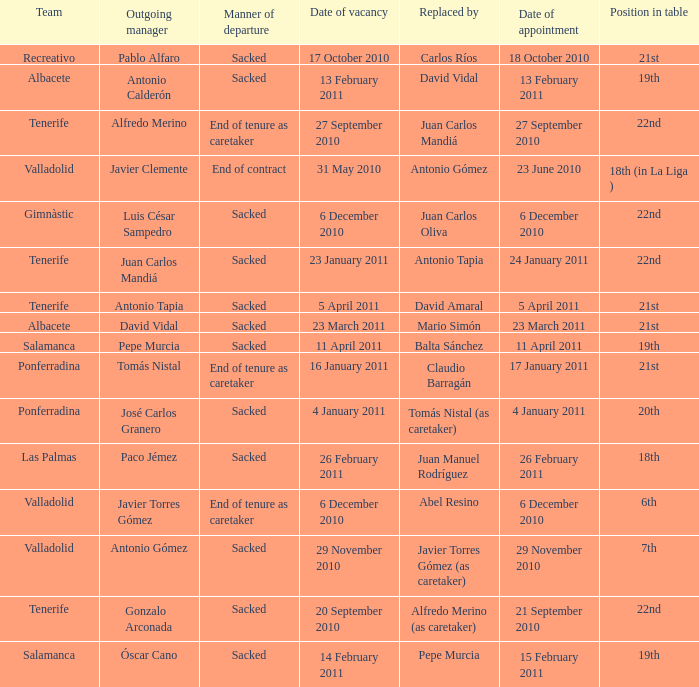What is the position for outgoing manager alfredo merino 22nd. Can you give me this table as a dict? {'header': ['Team', 'Outgoing manager', 'Manner of departure', 'Date of vacancy', 'Replaced by', 'Date of appointment', 'Position in table'], 'rows': [['Recreativo', 'Pablo Alfaro', 'Sacked', '17 October 2010', 'Carlos Ríos', '18 October 2010', '21st'], ['Albacete', 'Antonio Calderón', 'Sacked', '13 February 2011', 'David Vidal', '13 February 2011', '19th'], ['Tenerife', 'Alfredo Merino', 'End of tenure as caretaker', '27 September 2010', 'Juan Carlos Mandiá', '27 September 2010', '22nd'], ['Valladolid', 'Javier Clemente', 'End of contract', '31 May 2010', 'Antonio Gómez', '23 June 2010', '18th (in La Liga )'], ['Gimnàstic', 'Luis César Sampedro', 'Sacked', '6 December 2010', 'Juan Carlos Oliva', '6 December 2010', '22nd'], ['Tenerife', 'Juan Carlos Mandiá', 'Sacked', '23 January 2011', 'Antonio Tapia', '24 January 2011', '22nd'], ['Tenerife', 'Antonio Tapia', 'Sacked', '5 April 2011', 'David Amaral', '5 April 2011', '21st'], ['Albacete', 'David Vidal', 'Sacked', '23 March 2011', 'Mario Simón', '23 March 2011', '21st'], ['Salamanca', 'Pepe Murcia', 'Sacked', '11 April 2011', 'Balta Sánchez', '11 April 2011', '19th'], ['Ponferradina', 'Tomás Nistal', 'End of tenure as caretaker', '16 January 2011', 'Claudio Barragán', '17 January 2011', '21st'], ['Ponferradina', 'José Carlos Granero', 'Sacked', '4 January 2011', 'Tomás Nistal (as caretaker)', '4 January 2011', '20th'], ['Las Palmas', 'Paco Jémez', 'Sacked', '26 February 2011', 'Juan Manuel Rodríguez', '26 February 2011', '18th'], ['Valladolid', 'Javier Torres Gómez', 'End of tenure as caretaker', '6 December 2010', 'Abel Resino', '6 December 2010', '6th'], ['Valladolid', 'Antonio Gómez', 'Sacked', '29 November 2010', 'Javier Torres Gómez (as caretaker)', '29 November 2010', '7th'], ['Tenerife', 'Gonzalo Arconada', 'Sacked', '20 September 2010', 'Alfredo Merino (as caretaker)', '21 September 2010', '22nd'], ['Salamanca', 'Óscar Cano', 'Sacked', '14 February 2011', 'Pepe Murcia', '15 February 2011', '19th']]} 